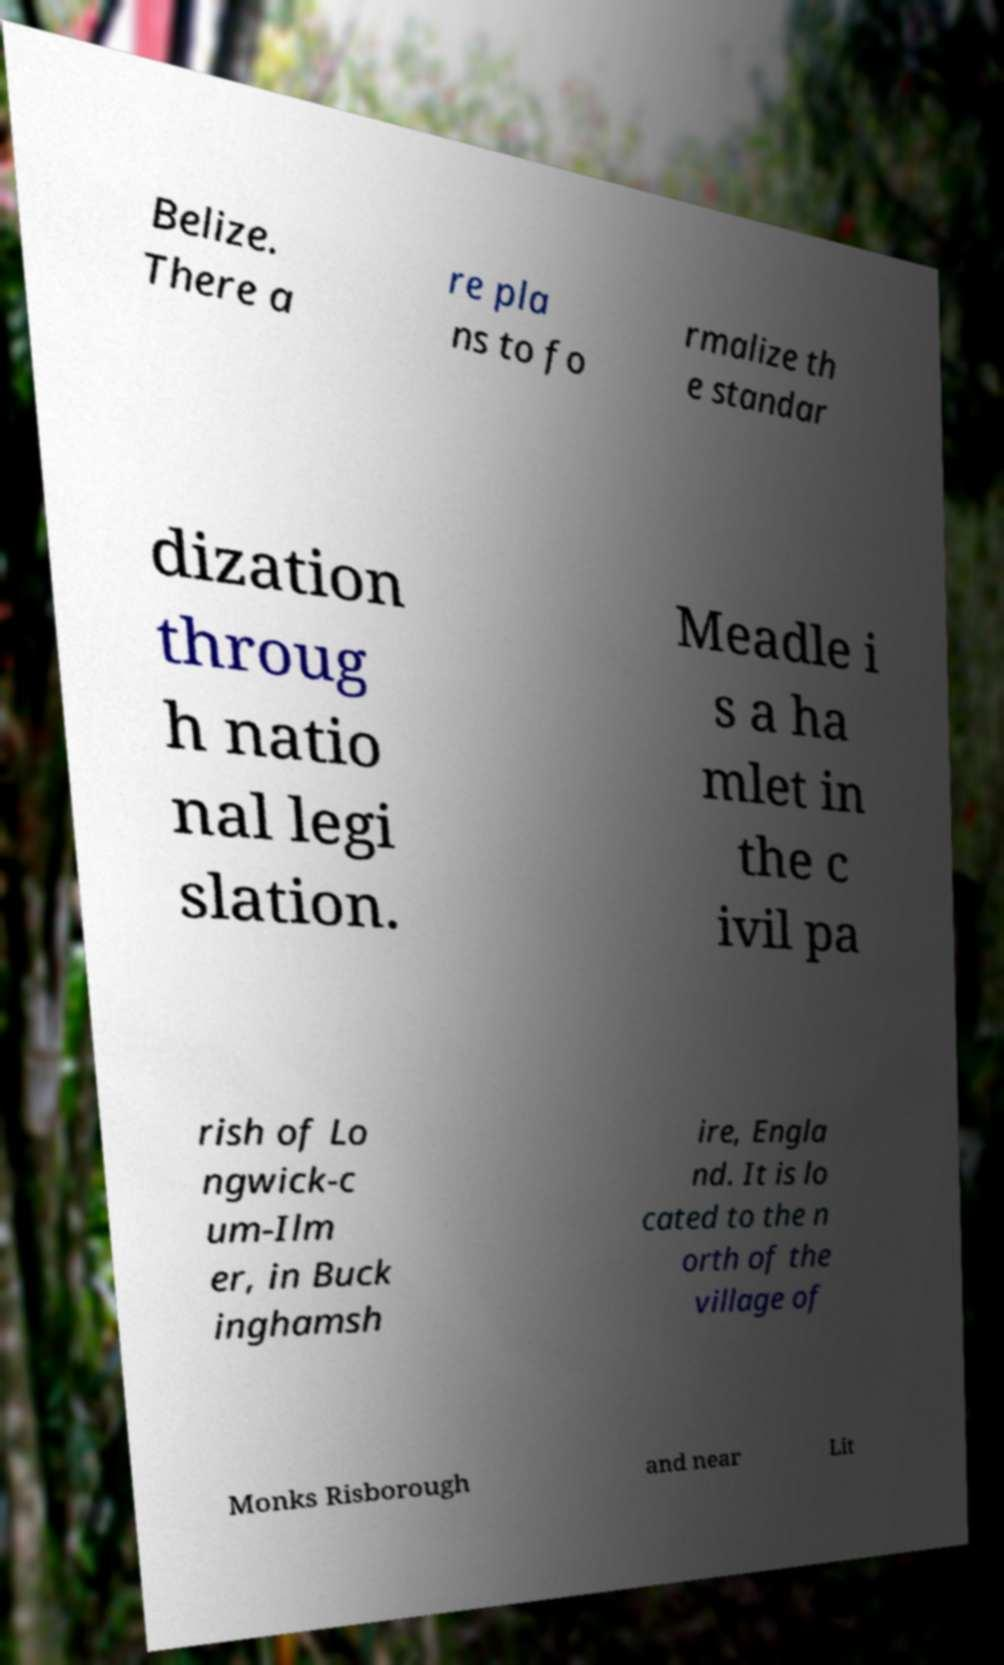Can you read and provide the text displayed in the image?This photo seems to have some interesting text. Can you extract and type it out for me? Belize. There a re pla ns to fo rmalize th e standar dization throug h natio nal legi slation. Meadle i s a ha mlet in the c ivil pa rish of Lo ngwick-c um-Ilm er, in Buck inghamsh ire, Engla nd. It is lo cated to the n orth of the village of Monks Risborough and near Lit 